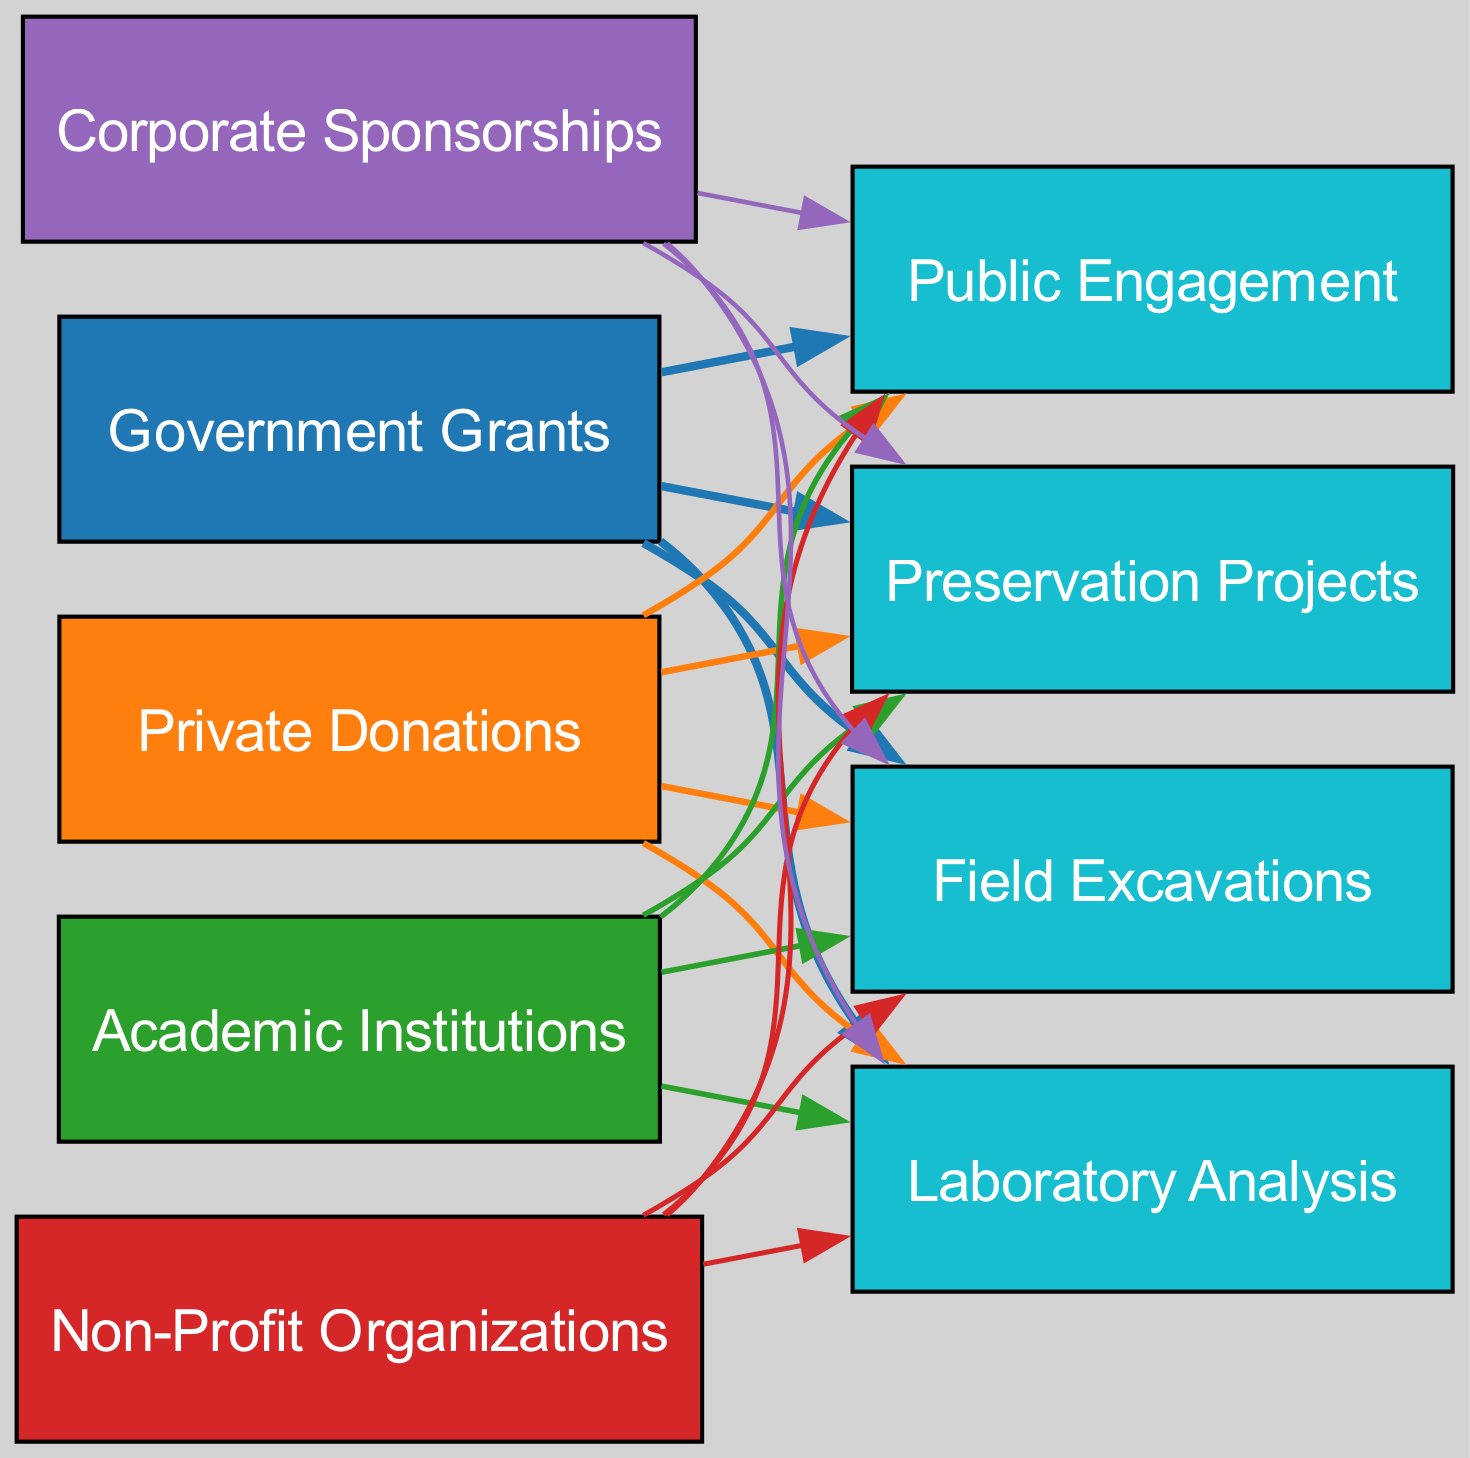What is the total amount of funding represented in the diagram? To determine the total amount of funding, add all the individual amounts from the funding sources: 45 + 25 + 15 + 10 + 5 = 100.
Answer: 100 Which funding source has the least amount? By evaluating the amounts associated with each funding source, Corporate Sponsorships has the lowest amount at 5.
Answer: Corporate Sponsorships How many total uses are represented in the diagram? The diagram includes four uses: Field Excavations, Laboratory Analysis, Public Engagement, and Preservation Projects. Count these to get the total.
Answer: 4 What percentage of funding comes from Government Grants? Government Grants contribute 45 to the total funding of 100. Calculate the percentage by dividing: (45/100) * 100 = 45%.
Answer: 45% Which use has the most funding directed towards it? All funding amounts are equally distributed among the uses. Each use receives a weighted amount from all sources. However, total amounts can be compared to see that there's no specific use favored; each receives 20 (since 100 / 5 sources = 20 per use). Thus, they are equally funded.
Answer: All uses (equal) What color represents Private Donations in the diagram? Private Donations is associated with the second funding source listed, which corresponds to the second color in the custom palette, '#ff7f0e'.
Answer: Orange How many edges are connected to Academic Institutions? Academic Institutions is one of the sources, and it has a connection to all four uses. Therefore, it has four edges connected to it.
Answer: 4 Which funding source contributes the highest amount towards Laboratory Analysis? Each source contributes an equal fraction of its total amount to each use. Since Academic Institutions has a specific amount of 15, it contributes 15/4 = 3.75 to Laboratory Analysis, but since it’s not above others, the highest is still Government Grants, contributing 45/4 = 11.25.
Answer: Government Grants What is the purpose of Non-Profit Organizations? Non-Profit Organizations provide support with a focus on heritage and cultural preservation, which helps fund various archaeological projects.
Answer: Support for heritage and cultural preservation 